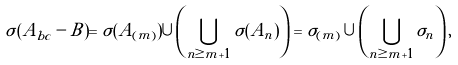<formula> <loc_0><loc_0><loc_500><loc_500>\sigma ( A _ { b c } - B ) = \sigma ( A _ { ( m ) } ) \cup \left ( \bigcup _ { n \geq m + 1 } \sigma ( A _ { n } ) \right ) = \sigma _ { ( m ) } \cup \left ( \bigcup _ { n \geq m + 1 } \sigma _ { n } \right ) ,</formula> 